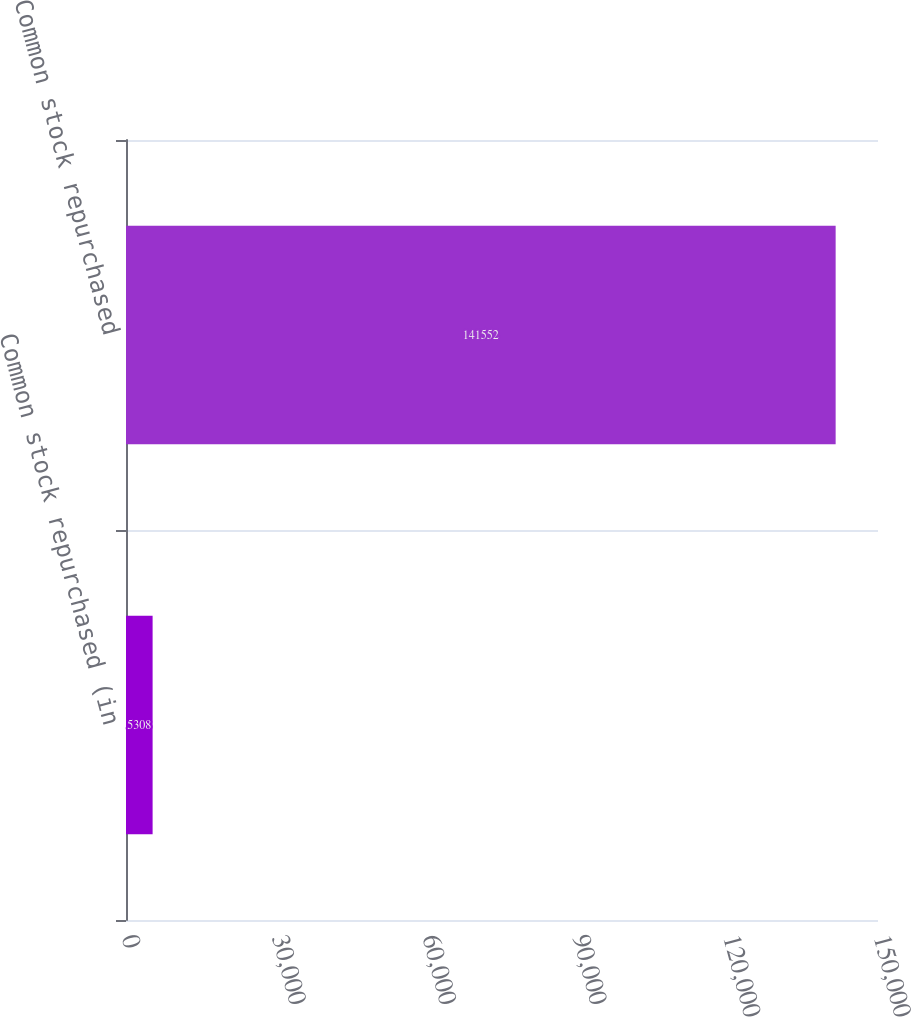Convert chart. <chart><loc_0><loc_0><loc_500><loc_500><bar_chart><fcel>Common stock repurchased (in<fcel>Common stock repurchased<nl><fcel>5308<fcel>141552<nl></chart> 